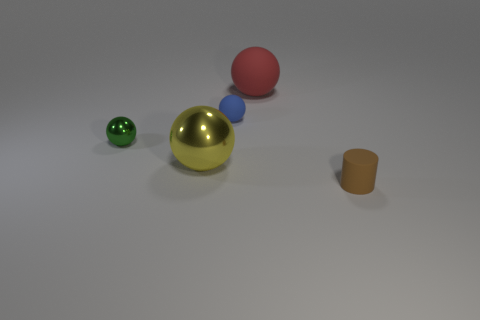What number of small objects are balls or yellow metallic balls?
Your answer should be compact. 2. Does the sphere on the right side of the blue rubber thing have the same size as the matte object that is on the right side of the red thing?
Offer a very short reply. No. The other rubber object that is the same shape as the blue matte object is what size?
Keep it short and to the point. Large. Is the number of tiny metal things that are right of the yellow metallic thing greater than the number of blue things that are in front of the tiny metallic ball?
Your answer should be compact. No. What material is the small object that is behind the tiny brown thing and on the right side of the yellow sphere?
Your response must be concise. Rubber. There is a small metallic object that is the same shape as the small blue matte object; what color is it?
Give a very brief answer. Green. The green metallic ball is what size?
Give a very brief answer. Small. The tiny matte thing in front of the small matte object that is behind the small brown cylinder is what color?
Your answer should be very brief. Brown. How many objects are in front of the red rubber object and left of the brown matte cylinder?
Provide a short and direct response. 3. Is the number of green shiny things greater than the number of big objects?
Offer a terse response. No. 